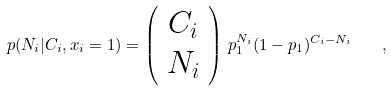<formula> <loc_0><loc_0><loc_500><loc_500>p ( N _ { i } | C _ { i } , x _ { i } = 1 ) = \left ( \begin{array} { c } C _ { i } \\ N _ { i } \end{array} \right ) \, p _ { 1 } ^ { N _ { i } } ( 1 - p _ { 1 } ) ^ { C _ { i } - N _ { i } } \quad ,</formula> 